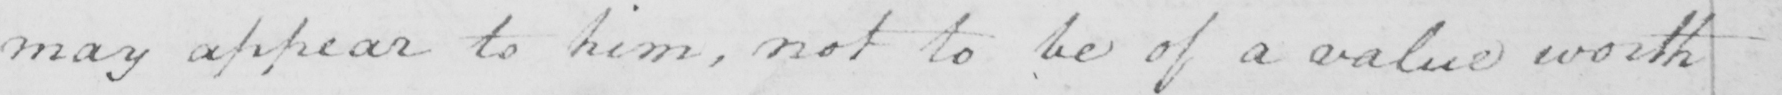Can you tell me what this handwritten text says? may appear to him , not to be of a value worth 